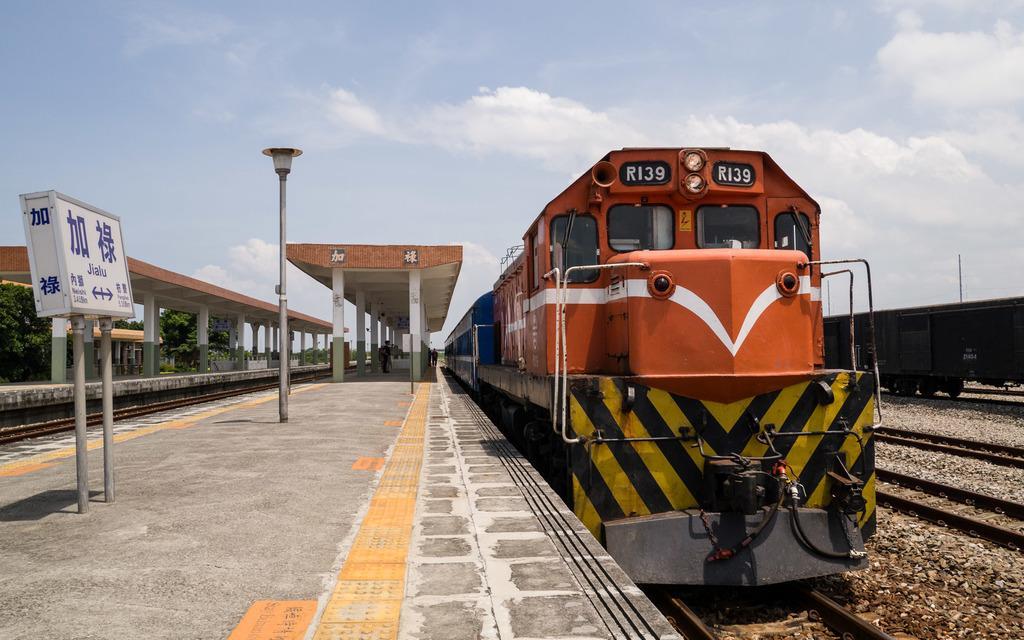In one or two sentences, can you explain what this image depicts? In this image we can see there are railway tracks and there are trains on the track. There are people standing on the ground and there is the shed with pillars. And there is the sign board attached to the pole. There are trees, light pole and the cloudy sky. 